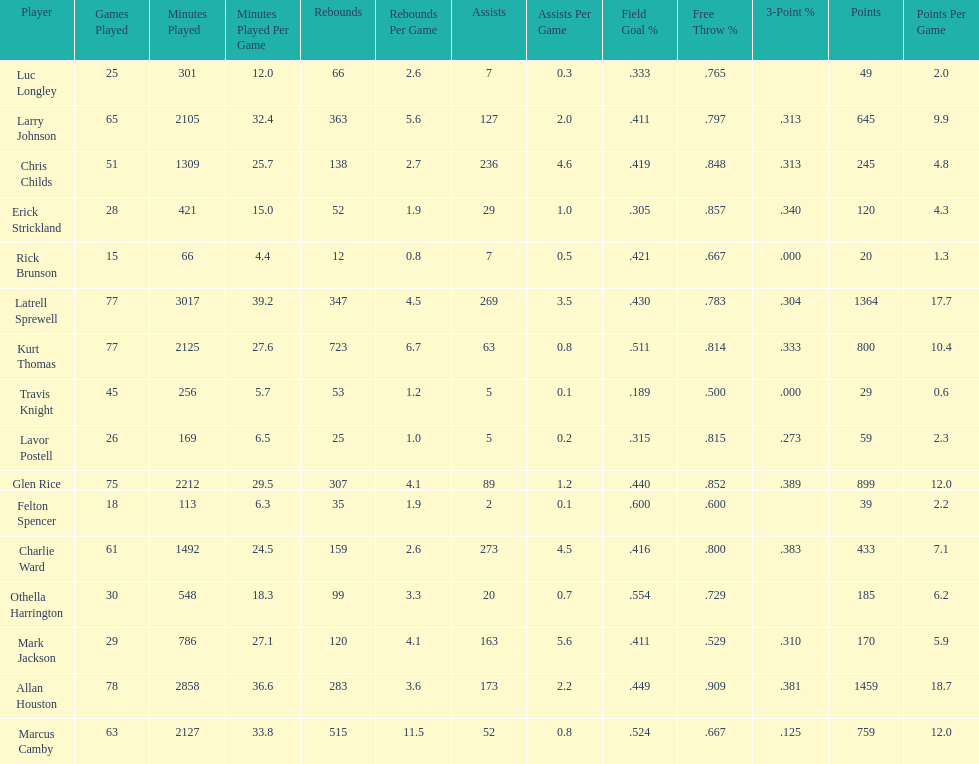Did kurt thomas play more or less than 2126 minutes? Less. 